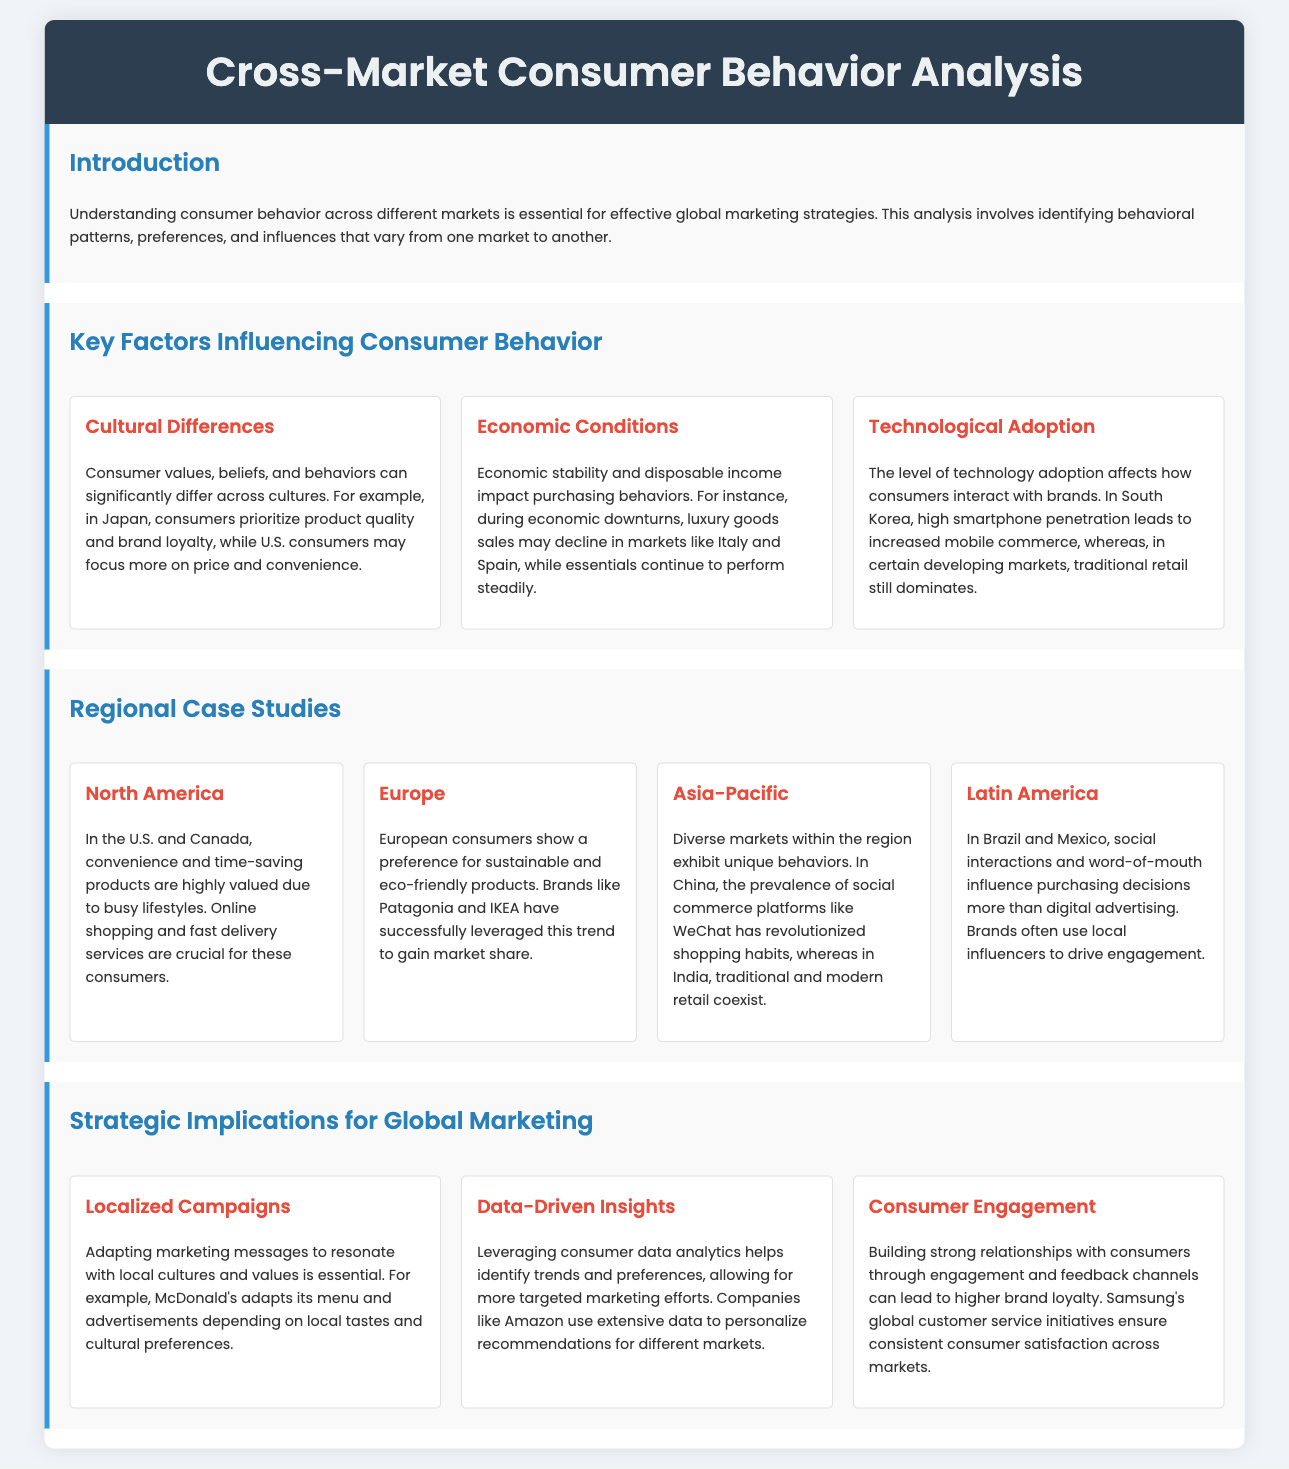What is the main focus of the analysis? The analysis focuses on understanding consumer behavior across different markets, identifying behavioral patterns, preferences, and influences.
Answer: Consumer behavior What cultural difference is highlighted in the document? The document states that in Japan, consumers prioritize product quality and brand loyalty.
Answer: Product quality and brand loyalty Which region shows a preference for sustainable products? The document mentions that European consumers show a preference for sustainable and eco-friendly products.
Answer: Europe What type of retail is still dominant in certain developing markets? The document indicates that traditional retail still dominates in certain developing markets.
Answer: Traditional retail What marketing strategy is suggested for adapting to local cultures? The document suggests adapting marketing messages to resonate with local cultures and values.
Answer: Localized Campaigns What technological impact is mentioned for South Korea? The document states that high smartphone penetration in South Korea leads to increased mobile commerce.
Answer: Increased mobile commerce How do Brazilian and Mexican consumers make purchasing decisions? The document notes that social interactions and word-of-mouth influence purchasing decisions more than digital advertising.
Answer: Social interactions and word-of-mouth Which company is given as an example for leveraging consumer data analytics? The document examples Amazon for using extensive data to personalize recommendations for different markets.
Answer: Amazon What is a key implication for consumer engagement? The document highlights that building strong relationships with consumers can lead to higher brand loyalty.
Answer: Higher brand loyalty 